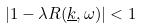<formula> <loc_0><loc_0><loc_500><loc_500>| 1 - \lambda R ( \underline { k } , \omega ) | < 1</formula> 